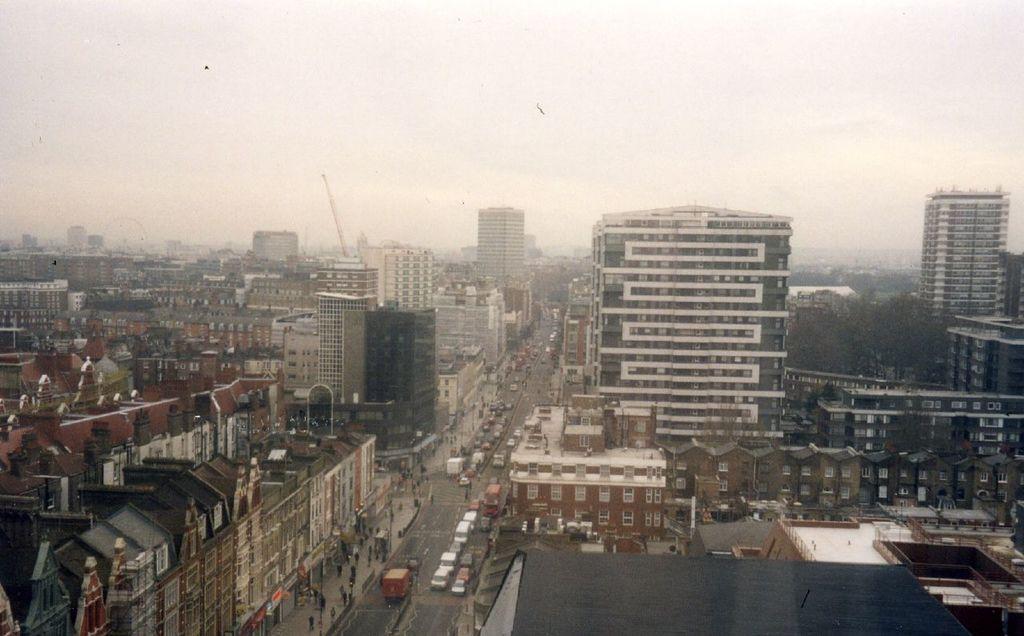Describe this image in one or two sentences. In the image there are a lot of buildings, road, vehicles and people. 